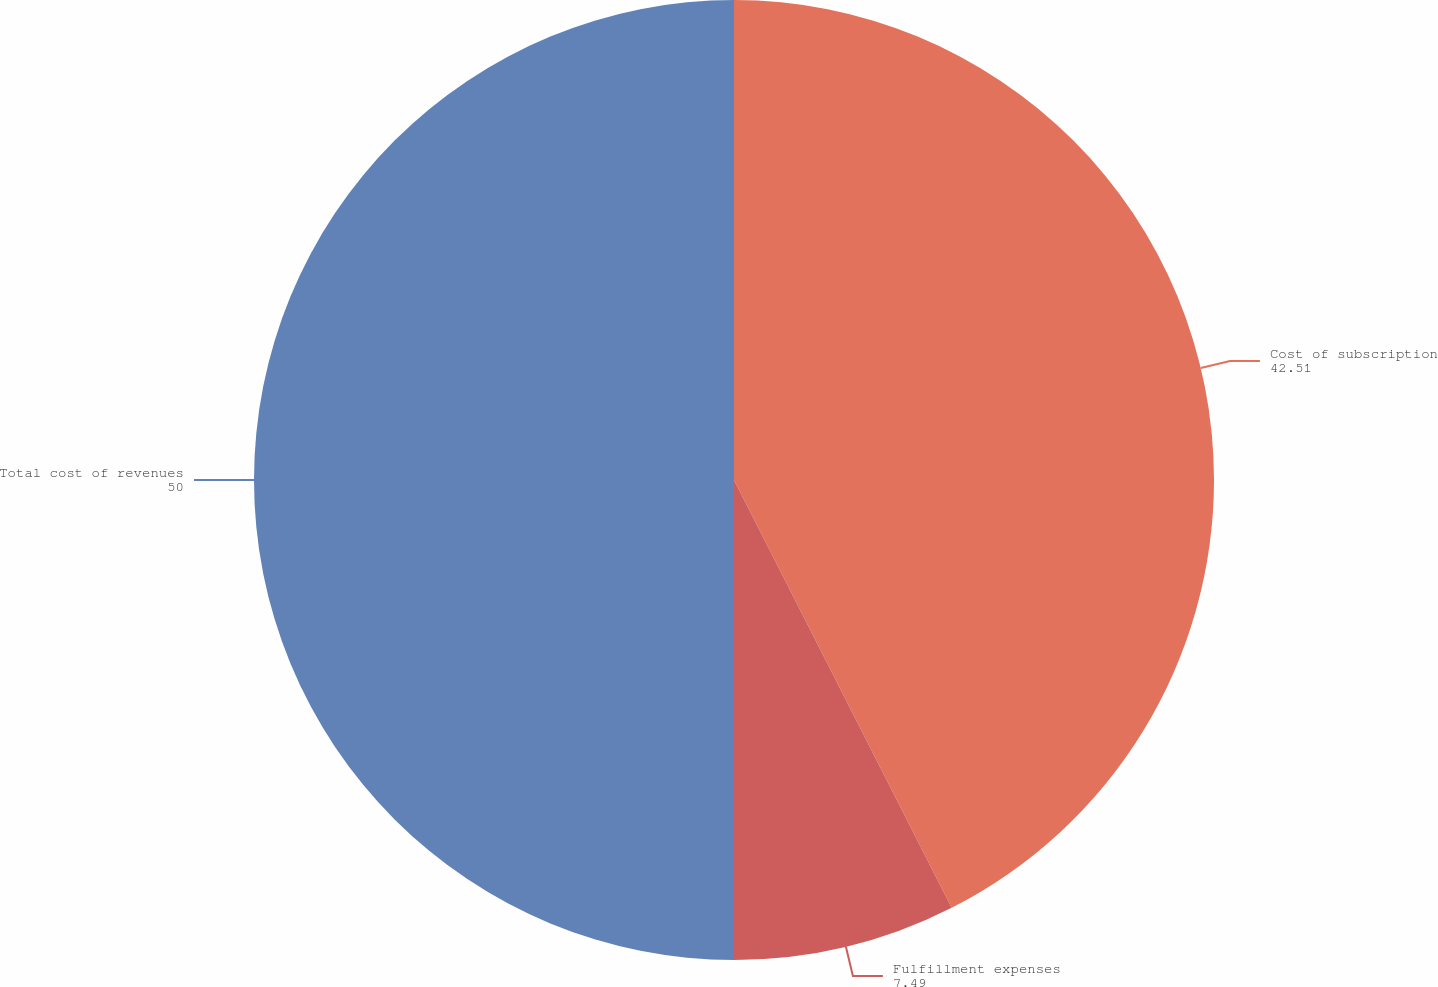<chart> <loc_0><loc_0><loc_500><loc_500><pie_chart><fcel>Cost of subscription<fcel>Fulfillment expenses<fcel>Total cost of revenues<nl><fcel>42.51%<fcel>7.49%<fcel>50.0%<nl></chart> 